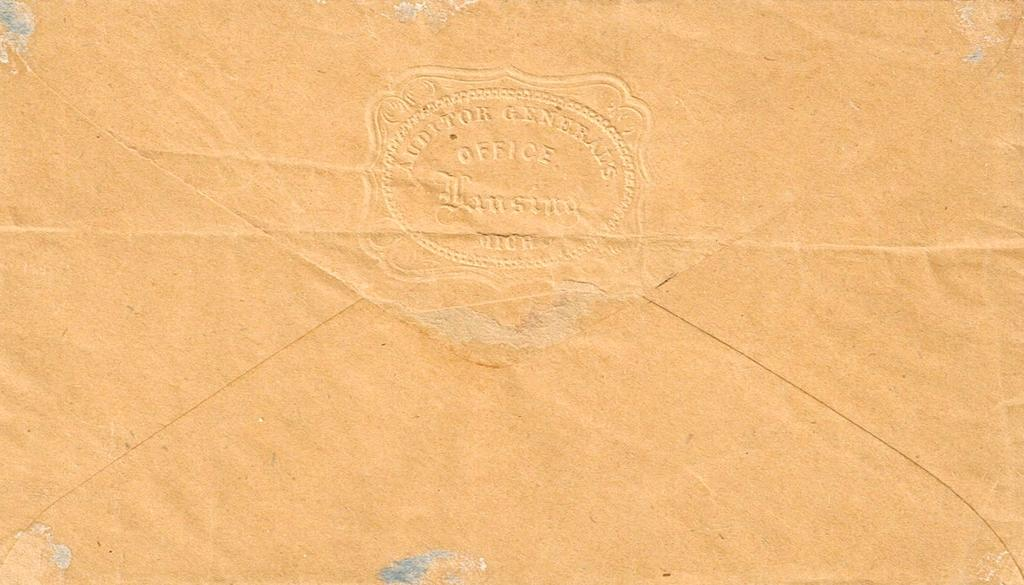<image>
Present a compact description of the photo's key features. An auditors General notary type stamp marks this orange envelope. 